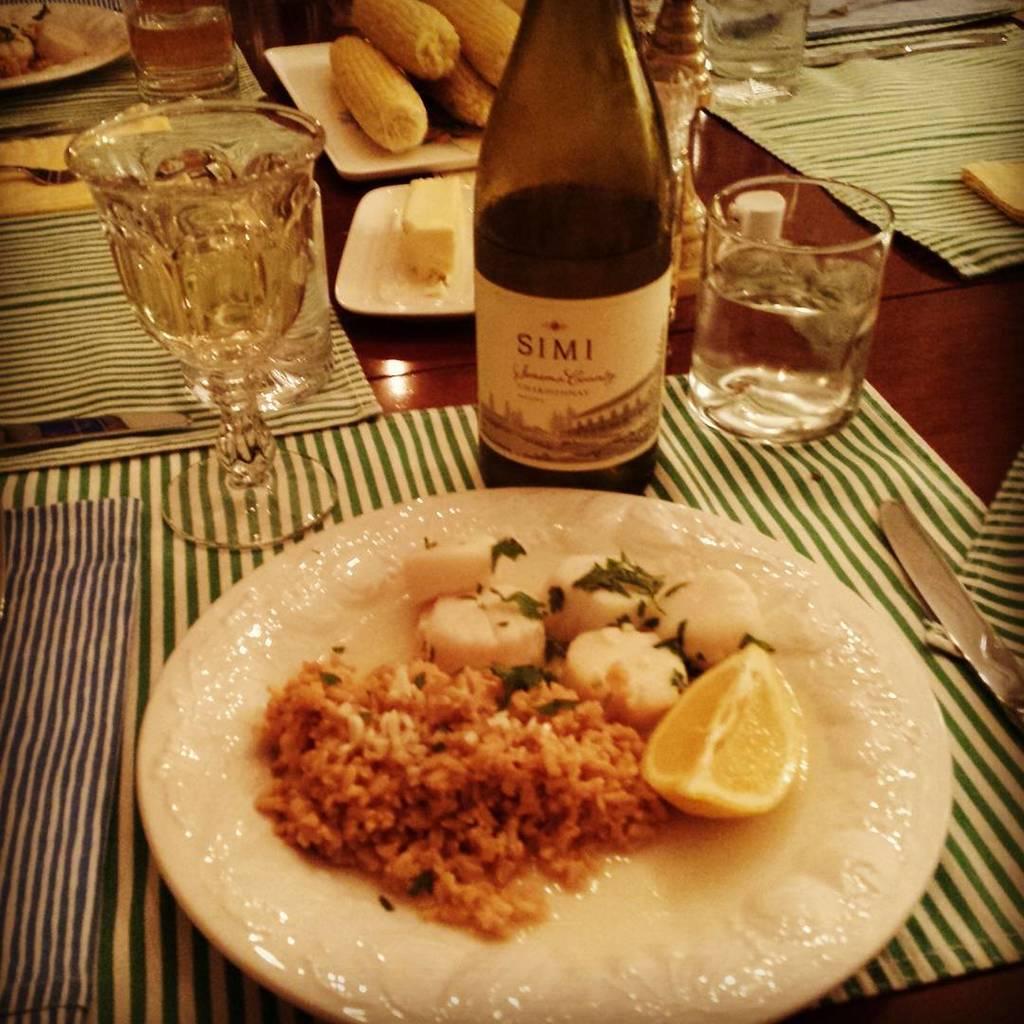What is the name of this wine?
Your answer should be very brief. Simi. 